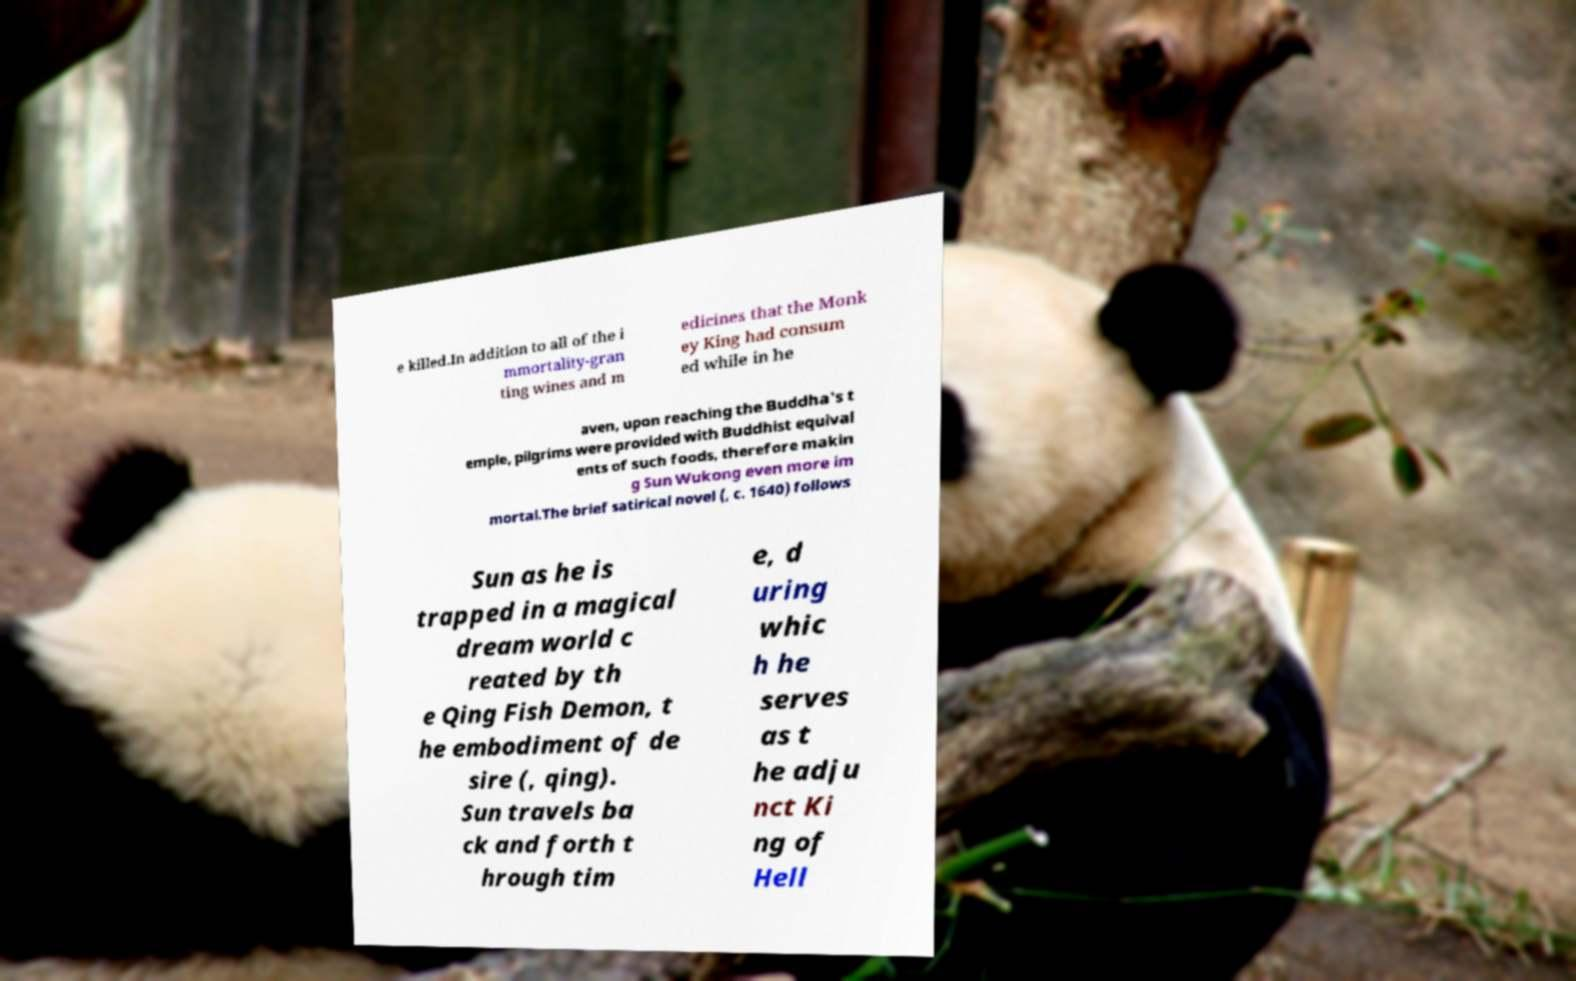Can you accurately transcribe the text from the provided image for me? e killed.In addition to all of the i mmortality-gran ting wines and m edicines that the Monk ey King had consum ed while in he aven, upon reaching the Buddha's t emple, pilgrims were provided with Buddhist equival ents of such foods, therefore makin g Sun Wukong even more im mortal.The brief satirical novel (, c. 1640) follows Sun as he is trapped in a magical dream world c reated by th e Qing Fish Demon, t he embodiment of de sire (, qing). Sun travels ba ck and forth t hrough tim e, d uring whic h he serves as t he adju nct Ki ng of Hell 